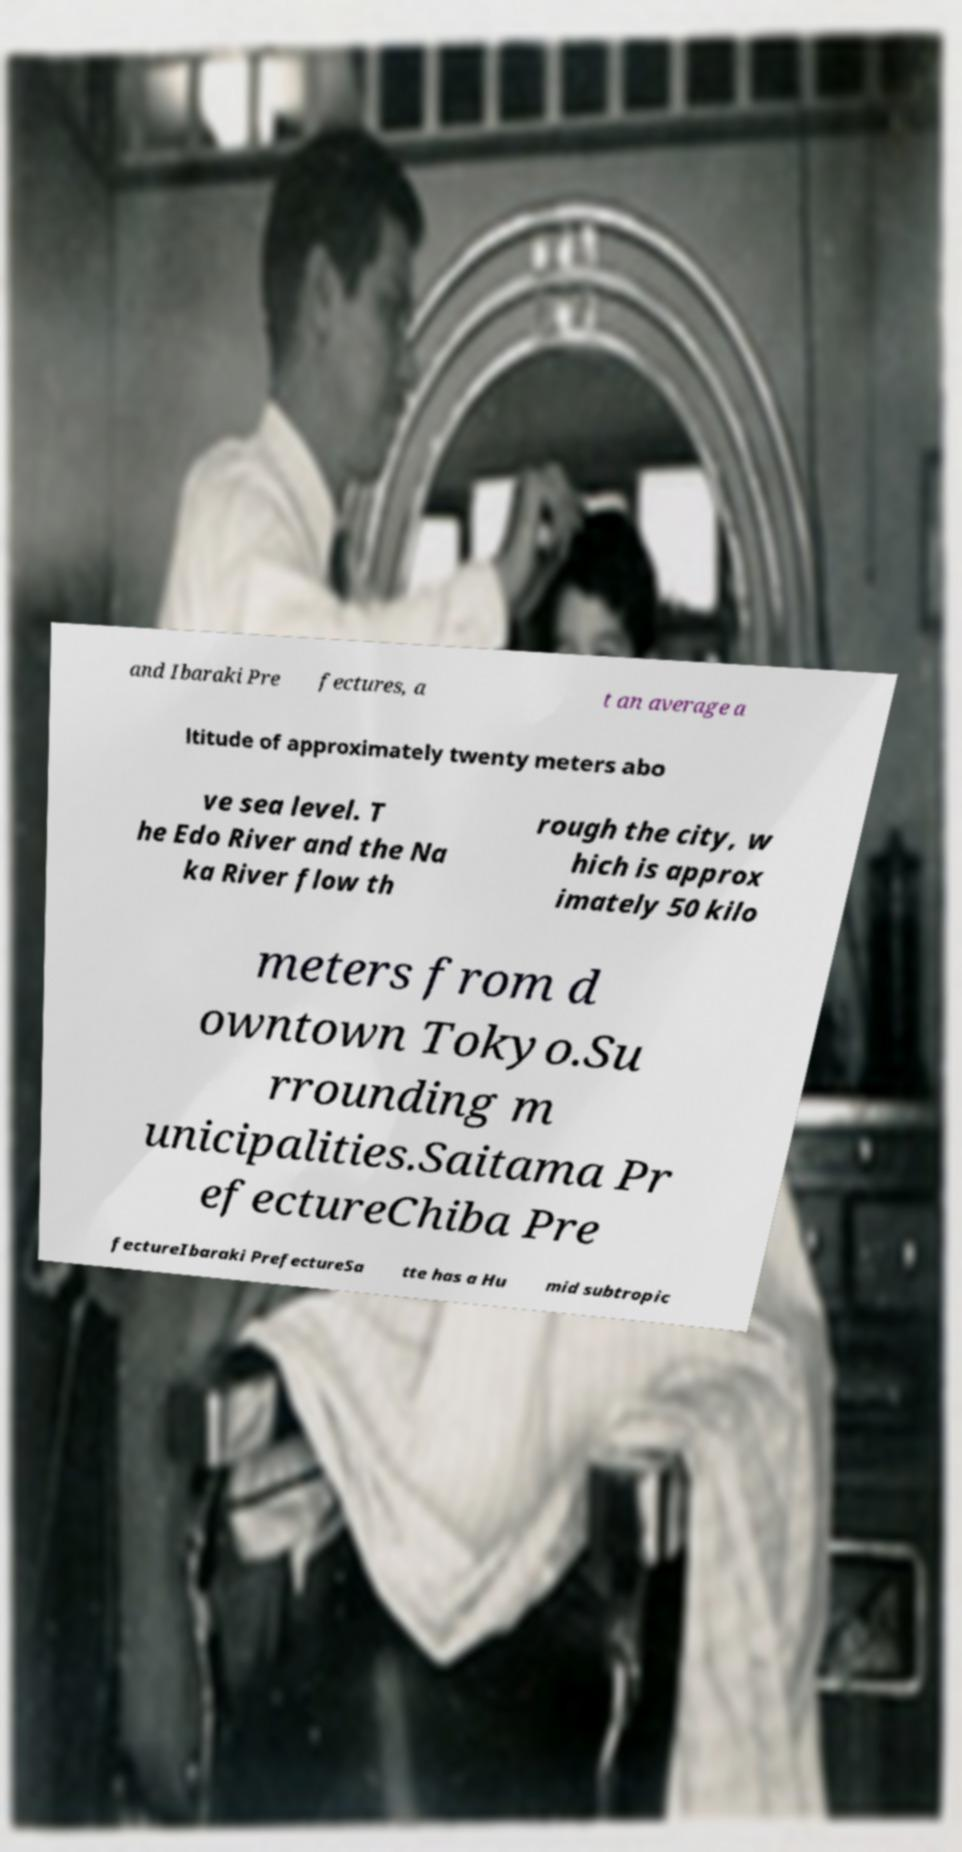Please read and relay the text visible in this image. What does it say? and Ibaraki Pre fectures, a t an average a ltitude of approximately twenty meters abo ve sea level. T he Edo River and the Na ka River flow th rough the city, w hich is approx imately 50 kilo meters from d owntown Tokyo.Su rrounding m unicipalities.Saitama Pr efectureChiba Pre fectureIbaraki PrefectureSa tte has a Hu mid subtropic 